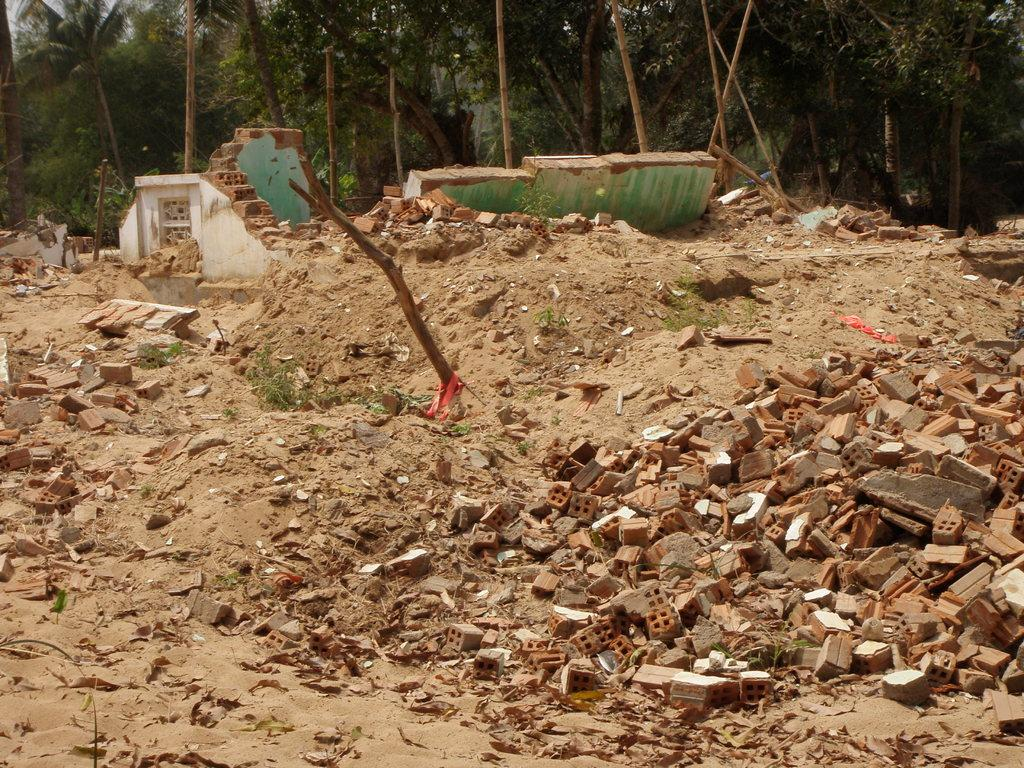What type of debris can be seen on the right side of the image? There are broken bricks on the right side of the image. What structure appears to be damaged in the image? There is a broken wall in the image. What type of natural environment is visible in the background of the image? There are trees in the background of the image. What type of terrain is visible in the image? Sand is visible in the image. What type of powder is being used to repair the broken wall in the image? There is no powder visible in the image, nor is there any indication of repair work being done. Who is the owner of the property in the image? There is no information about property ownership in the image. 